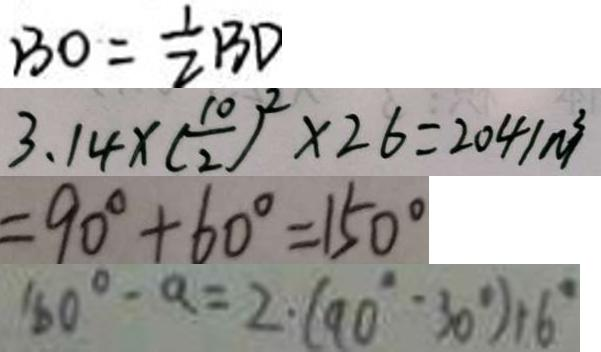<formula> <loc_0><loc_0><loc_500><loc_500>B O = \frac { 1 } { 2 } B D 
 3 . 1 4 \times ( \frac { 1 0 } { 2 } ) ^ { 2 } \times 2 6 = 2 0 4 1 m ^ { 3 } 
 = 9 0 ^ { \circ } + 6 0 ^ { \circ } = 1 5 0 ^ { \circ } 
 1 6 0 ^ { \circ } - a = 2 \cdot ( 9 0 ^ { \circ } \cdot 3 0 ^ { \circ } ) + 6 ^ { \circ }</formula> 